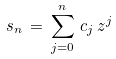Convert formula to latex. <formula><loc_0><loc_0><loc_500><loc_500>s _ { n } \, = \, \sum _ { j = 0 } ^ { n } \, c _ { j } \, z ^ { j }</formula> 